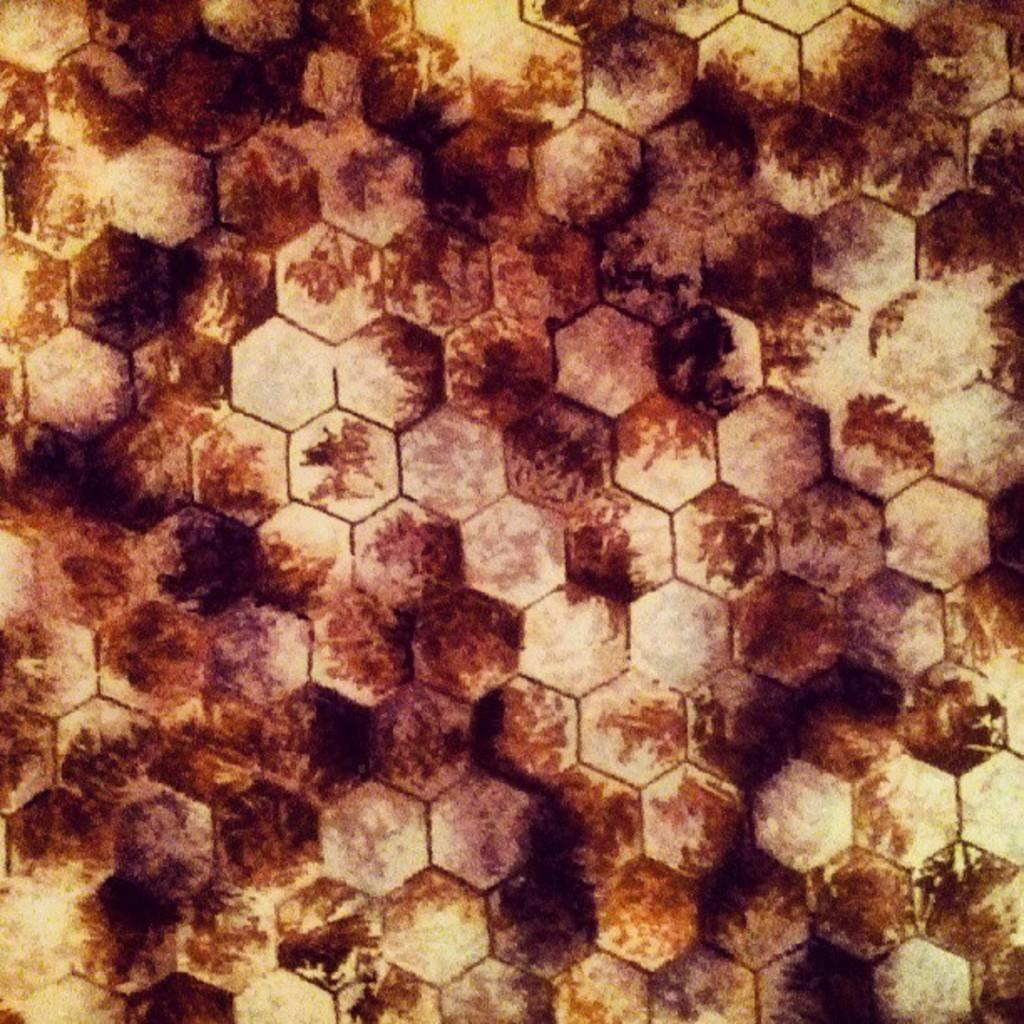What is the main subject visible in the image? There is a surface visible in the image. Can you describe any specific features or characteristics of the surface? Yes, there are marks on the surface. Where is the playground located in the image? There is no playground present in the image. What type of ground is visible in the image? The image only shows a surface with marks on it, and there is no specific type of ground mentioned or visible. Is there a prison visible in the image? There is no prison present in the image. 